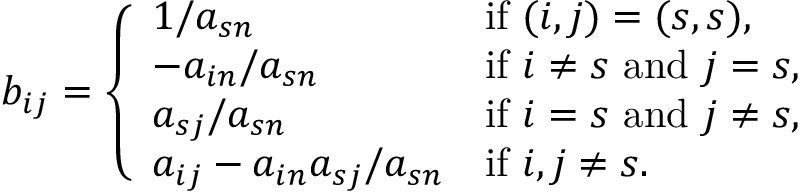Convert formula to latex. <formula><loc_0><loc_0><loc_500><loc_500>b _ { i j } = \left \{ \begin{array} { l l } { 1 / a _ { s n } } & { i f ( i , j ) = ( s , s ) , } \\ { - a _ { i n } / a _ { s n } } & { i f i \neq s a n d j = s , } \\ { a _ { s j } / a _ { s n } } & { i f i = s a n d j \neq s , } \\ { a _ { i j } - a _ { i n } a _ { s j } / a _ { s n } } & { i f i , j \neq s . } \end{array}</formula> 